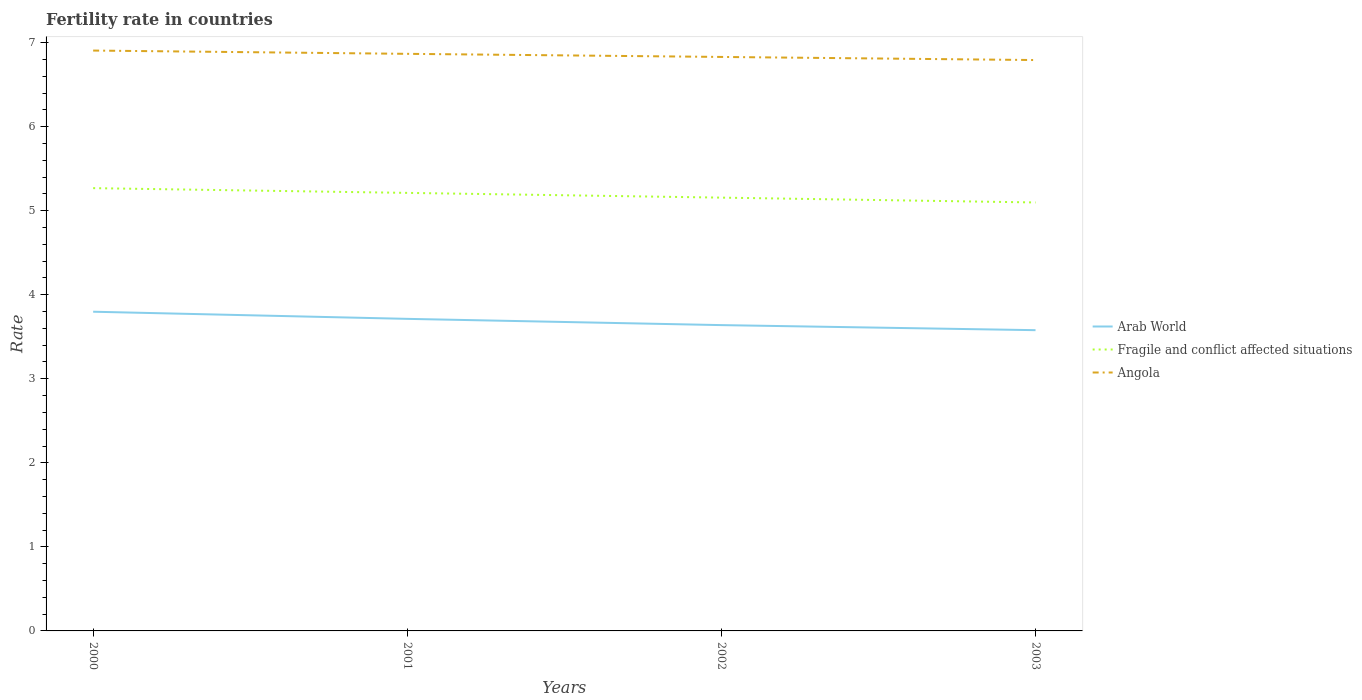Does the line corresponding to Angola intersect with the line corresponding to Fragile and conflict affected situations?
Offer a terse response. No. Is the number of lines equal to the number of legend labels?
Your response must be concise. Yes. Across all years, what is the maximum fertility rate in Fragile and conflict affected situations?
Provide a short and direct response. 5.1. In which year was the fertility rate in Fragile and conflict affected situations maximum?
Your response must be concise. 2003. What is the total fertility rate in Fragile and conflict affected situations in the graph?
Ensure brevity in your answer.  0.17. What is the difference between the highest and the second highest fertility rate in Arab World?
Keep it short and to the point. 0.22. Is the fertility rate in Angola strictly greater than the fertility rate in Arab World over the years?
Your answer should be compact. No. How many years are there in the graph?
Provide a short and direct response. 4. Are the values on the major ticks of Y-axis written in scientific E-notation?
Give a very brief answer. No. Does the graph contain grids?
Keep it short and to the point. No. Where does the legend appear in the graph?
Offer a very short reply. Center right. How are the legend labels stacked?
Offer a very short reply. Vertical. What is the title of the graph?
Ensure brevity in your answer.  Fertility rate in countries. Does "Hungary" appear as one of the legend labels in the graph?
Offer a very short reply. No. What is the label or title of the X-axis?
Keep it short and to the point. Years. What is the label or title of the Y-axis?
Ensure brevity in your answer.  Rate. What is the Rate of Arab World in 2000?
Your response must be concise. 3.8. What is the Rate in Fragile and conflict affected situations in 2000?
Your answer should be compact. 5.27. What is the Rate in Angola in 2000?
Your answer should be very brief. 6.91. What is the Rate in Arab World in 2001?
Offer a terse response. 3.71. What is the Rate in Fragile and conflict affected situations in 2001?
Ensure brevity in your answer.  5.21. What is the Rate in Angola in 2001?
Offer a very short reply. 6.87. What is the Rate in Arab World in 2002?
Give a very brief answer. 3.64. What is the Rate in Fragile and conflict affected situations in 2002?
Give a very brief answer. 5.16. What is the Rate in Angola in 2002?
Your response must be concise. 6.83. What is the Rate in Arab World in 2003?
Ensure brevity in your answer.  3.58. What is the Rate in Fragile and conflict affected situations in 2003?
Provide a succinct answer. 5.1. What is the Rate of Angola in 2003?
Make the answer very short. 6.79. Across all years, what is the maximum Rate of Arab World?
Offer a terse response. 3.8. Across all years, what is the maximum Rate in Fragile and conflict affected situations?
Provide a succinct answer. 5.27. Across all years, what is the maximum Rate of Angola?
Make the answer very short. 6.91. Across all years, what is the minimum Rate in Arab World?
Give a very brief answer. 3.58. Across all years, what is the minimum Rate in Fragile and conflict affected situations?
Your answer should be very brief. 5.1. Across all years, what is the minimum Rate of Angola?
Make the answer very short. 6.79. What is the total Rate in Arab World in the graph?
Ensure brevity in your answer.  14.73. What is the total Rate of Fragile and conflict affected situations in the graph?
Provide a short and direct response. 20.73. What is the total Rate in Angola in the graph?
Offer a very short reply. 27.39. What is the difference between the Rate in Arab World in 2000 and that in 2001?
Provide a succinct answer. 0.08. What is the difference between the Rate in Fragile and conflict affected situations in 2000 and that in 2001?
Offer a terse response. 0.06. What is the difference between the Rate in Angola in 2000 and that in 2001?
Your answer should be compact. 0.04. What is the difference between the Rate in Arab World in 2000 and that in 2002?
Your response must be concise. 0.16. What is the difference between the Rate of Fragile and conflict affected situations in 2000 and that in 2002?
Keep it short and to the point. 0.11. What is the difference between the Rate of Angola in 2000 and that in 2002?
Give a very brief answer. 0.08. What is the difference between the Rate in Arab World in 2000 and that in 2003?
Offer a very short reply. 0.22. What is the difference between the Rate in Fragile and conflict affected situations in 2000 and that in 2003?
Give a very brief answer. 0.17. What is the difference between the Rate in Angola in 2000 and that in 2003?
Offer a very short reply. 0.11. What is the difference between the Rate of Arab World in 2001 and that in 2002?
Your response must be concise. 0.07. What is the difference between the Rate in Fragile and conflict affected situations in 2001 and that in 2002?
Your answer should be compact. 0.06. What is the difference between the Rate in Angola in 2001 and that in 2002?
Make the answer very short. 0.04. What is the difference between the Rate in Arab World in 2001 and that in 2003?
Provide a short and direct response. 0.13. What is the difference between the Rate of Fragile and conflict affected situations in 2001 and that in 2003?
Your answer should be compact. 0.11. What is the difference between the Rate in Angola in 2001 and that in 2003?
Your answer should be compact. 0.07. What is the difference between the Rate in Arab World in 2002 and that in 2003?
Make the answer very short. 0.06. What is the difference between the Rate of Fragile and conflict affected situations in 2002 and that in 2003?
Provide a succinct answer. 0.06. What is the difference between the Rate in Angola in 2002 and that in 2003?
Ensure brevity in your answer.  0.04. What is the difference between the Rate in Arab World in 2000 and the Rate in Fragile and conflict affected situations in 2001?
Your response must be concise. -1.41. What is the difference between the Rate of Arab World in 2000 and the Rate of Angola in 2001?
Your answer should be very brief. -3.07. What is the difference between the Rate of Fragile and conflict affected situations in 2000 and the Rate of Angola in 2001?
Offer a terse response. -1.6. What is the difference between the Rate in Arab World in 2000 and the Rate in Fragile and conflict affected situations in 2002?
Keep it short and to the point. -1.36. What is the difference between the Rate in Arab World in 2000 and the Rate in Angola in 2002?
Ensure brevity in your answer.  -3.03. What is the difference between the Rate of Fragile and conflict affected situations in 2000 and the Rate of Angola in 2002?
Your answer should be very brief. -1.56. What is the difference between the Rate in Arab World in 2000 and the Rate in Fragile and conflict affected situations in 2003?
Ensure brevity in your answer.  -1.3. What is the difference between the Rate in Arab World in 2000 and the Rate in Angola in 2003?
Offer a terse response. -2.99. What is the difference between the Rate in Fragile and conflict affected situations in 2000 and the Rate in Angola in 2003?
Give a very brief answer. -1.52. What is the difference between the Rate in Arab World in 2001 and the Rate in Fragile and conflict affected situations in 2002?
Offer a very short reply. -1.44. What is the difference between the Rate in Arab World in 2001 and the Rate in Angola in 2002?
Your response must be concise. -3.12. What is the difference between the Rate of Fragile and conflict affected situations in 2001 and the Rate of Angola in 2002?
Offer a terse response. -1.62. What is the difference between the Rate of Arab World in 2001 and the Rate of Fragile and conflict affected situations in 2003?
Offer a very short reply. -1.38. What is the difference between the Rate of Arab World in 2001 and the Rate of Angola in 2003?
Make the answer very short. -3.08. What is the difference between the Rate in Fragile and conflict affected situations in 2001 and the Rate in Angola in 2003?
Provide a succinct answer. -1.58. What is the difference between the Rate in Arab World in 2002 and the Rate in Fragile and conflict affected situations in 2003?
Your response must be concise. -1.46. What is the difference between the Rate in Arab World in 2002 and the Rate in Angola in 2003?
Your answer should be very brief. -3.15. What is the difference between the Rate in Fragile and conflict affected situations in 2002 and the Rate in Angola in 2003?
Your answer should be compact. -1.64. What is the average Rate in Arab World per year?
Offer a terse response. 3.68. What is the average Rate in Fragile and conflict affected situations per year?
Your answer should be very brief. 5.18. What is the average Rate in Angola per year?
Provide a succinct answer. 6.85. In the year 2000, what is the difference between the Rate of Arab World and Rate of Fragile and conflict affected situations?
Your answer should be very brief. -1.47. In the year 2000, what is the difference between the Rate in Arab World and Rate in Angola?
Keep it short and to the point. -3.11. In the year 2000, what is the difference between the Rate in Fragile and conflict affected situations and Rate in Angola?
Offer a terse response. -1.64. In the year 2001, what is the difference between the Rate of Arab World and Rate of Fragile and conflict affected situations?
Ensure brevity in your answer.  -1.5. In the year 2001, what is the difference between the Rate in Arab World and Rate in Angola?
Provide a succinct answer. -3.15. In the year 2001, what is the difference between the Rate of Fragile and conflict affected situations and Rate of Angola?
Offer a terse response. -1.65. In the year 2002, what is the difference between the Rate of Arab World and Rate of Fragile and conflict affected situations?
Give a very brief answer. -1.52. In the year 2002, what is the difference between the Rate in Arab World and Rate in Angola?
Offer a terse response. -3.19. In the year 2002, what is the difference between the Rate of Fragile and conflict affected situations and Rate of Angola?
Give a very brief answer. -1.67. In the year 2003, what is the difference between the Rate in Arab World and Rate in Fragile and conflict affected situations?
Provide a short and direct response. -1.52. In the year 2003, what is the difference between the Rate in Arab World and Rate in Angola?
Your response must be concise. -3.21. In the year 2003, what is the difference between the Rate of Fragile and conflict affected situations and Rate of Angola?
Offer a terse response. -1.69. What is the ratio of the Rate in Arab World in 2000 to that in 2001?
Ensure brevity in your answer.  1.02. What is the ratio of the Rate in Fragile and conflict affected situations in 2000 to that in 2001?
Provide a succinct answer. 1.01. What is the ratio of the Rate in Angola in 2000 to that in 2001?
Your response must be concise. 1.01. What is the ratio of the Rate in Arab World in 2000 to that in 2002?
Provide a short and direct response. 1.04. What is the ratio of the Rate in Fragile and conflict affected situations in 2000 to that in 2002?
Keep it short and to the point. 1.02. What is the ratio of the Rate in Angola in 2000 to that in 2002?
Make the answer very short. 1.01. What is the ratio of the Rate of Arab World in 2000 to that in 2003?
Give a very brief answer. 1.06. What is the ratio of the Rate in Fragile and conflict affected situations in 2000 to that in 2003?
Offer a terse response. 1.03. What is the ratio of the Rate of Angola in 2000 to that in 2003?
Offer a very short reply. 1.02. What is the ratio of the Rate of Arab World in 2001 to that in 2002?
Ensure brevity in your answer.  1.02. What is the ratio of the Rate in Fragile and conflict affected situations in 2001 to that in 2002?
Provide a short and direct response. 1.01. What is the ratio of the Rate of Angola in 2001 to that in 2002?
Make the answer very short. 1.01. What is the ratio of the Rate of Arab World in 2001 to that in 2003?
Your answer should be very brief. 1.04. What is the ratio of the Rate in Fragile and conflict affected situations in 2001 to that in 2003?
Ensure brevity in your answer.  1.02. What is the ratio of the Rate in Angola in 2001 to that in 2003?
Offer a terse response. 1.01. What is the ratio of the Rate in Arab World in 2002 to that in 2003?
Offer a terse response. 1.02. What is the ratio of the Rate in Fragile and conflict affected situations in 2002 to that in 2003?
Offer a terse response. 1.01. What is the ratio of the Rate in Angola in 2002 to that in 2003?
Make the answer very short. 1.01. What is the difference between the highest and the second highest Rate of Arab World?
Your answer should be very brief. 0.08. What is the difference between the highest and the second highest Rate in Fragile and conflict affected situations?
Ensure brevity in your answer.  0.06. What is the difference between the highest and the second highest Rate in Angola?
Provide a succinct answer. 0.04. What is the difference between the highest and the lowest Rate in Arab World?
Keep it short and to the point. 0.22. What is the difference between the highest and the lowest Rate in Fragile and conflict affected situations?
Your answer should be very brief. 0.17. What is the difference between the highest and the lowest Rate of Angola?
Offer a very short reply. 0.11. 